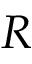<formula> <loc_0><loc_0><loc_500><loc_500>R</formula> 